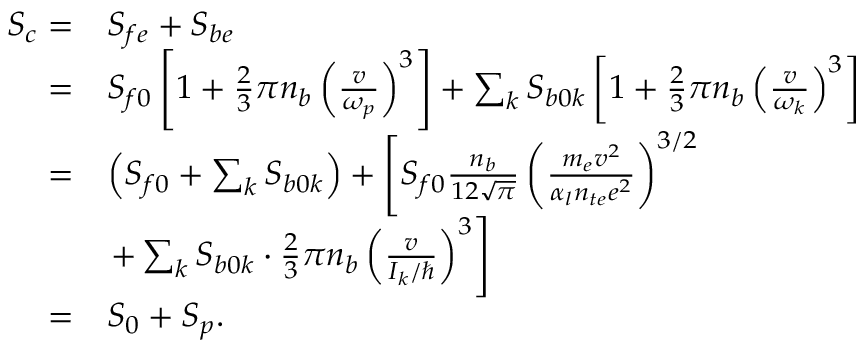<formula> <loc_0><loc_0><loc_500><loc_500>\begin{array} { r l } { S _ { c } = } & { S _ { f e } + S _ { b e } } \\ { = } & { S _ { f 0 } \left [ 1 + \frac { 2 } { 3 } \pi n _ { b } \left ( \frac { v } { \omega _ { p } } \right ) ^ { 3 } \right ] + \sum _ { k } S _ { b 0 k } \left [ 1 + \frac { 2 } { 3 } \pi n _ { b } \left ( \frac { v } { \omega _ { k } } \right ) ^ { 3 } \right ] } \\ { = } & { \left ( S _ { f 0 } + \sum _ { k } S _ { b 0 k } \right ) + \left [ S _ { f 0 } \frac { n _ { b } } { 1 2 \sqrt { \pi } } \left ( \frac { m _ { e } v ^ { 2 } } { \alpha _ { l } n _ { t e } e ^ { 2 } } \right ) ^ { 3 / 2 } } \\ & { + \sum _ { k } S _ { b 0 k } \cdot \frac { 2 } { 3 } \pi n _ { b } \left ( \frac { v } { I _ { k } / } \right ) ^ { 3 } \right ] } \\ { = } & { S _ { 0 } + S _ { p } . } \end{array}</formula> 